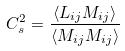<formula> <loc_0><loc_0><loc_500><loc_500>C _ { s } ^ { 2 } = \frac { \langle L _ { i j } M _ { i j } \rangle } { \langle M _ { i j } M _ { i j } \rangle }</formula> 